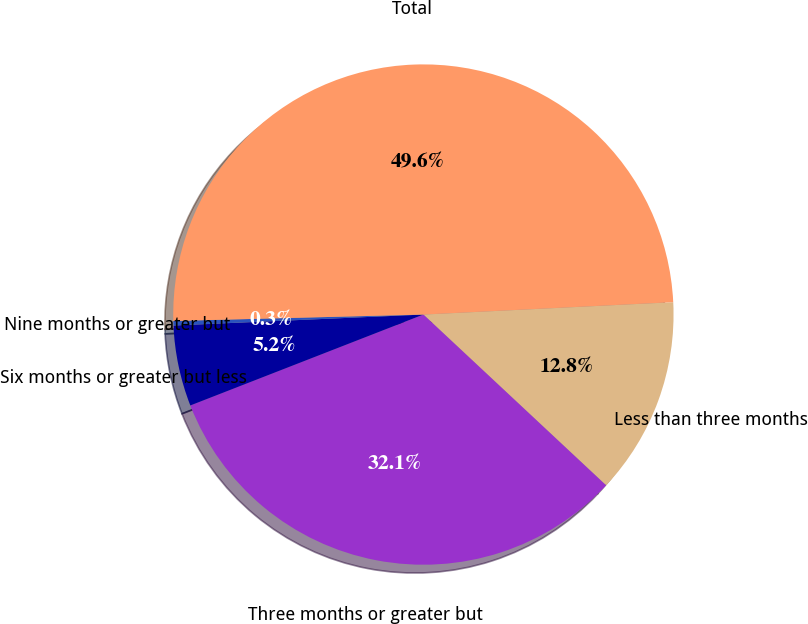Convert chart. <chart><loc_0><loc_0><loc_500><loc_500><pie_chart><fcel>Less than three months<fcel>Three months or greater but<fcel>Six months or greater but less<fcel>Nine months or greater but<fcel>Total<nl><fcel>12.75%<fcel>32.12%<fcel>5.22%<fcel>0.29%<fcel>49.62%<nl></chart> 